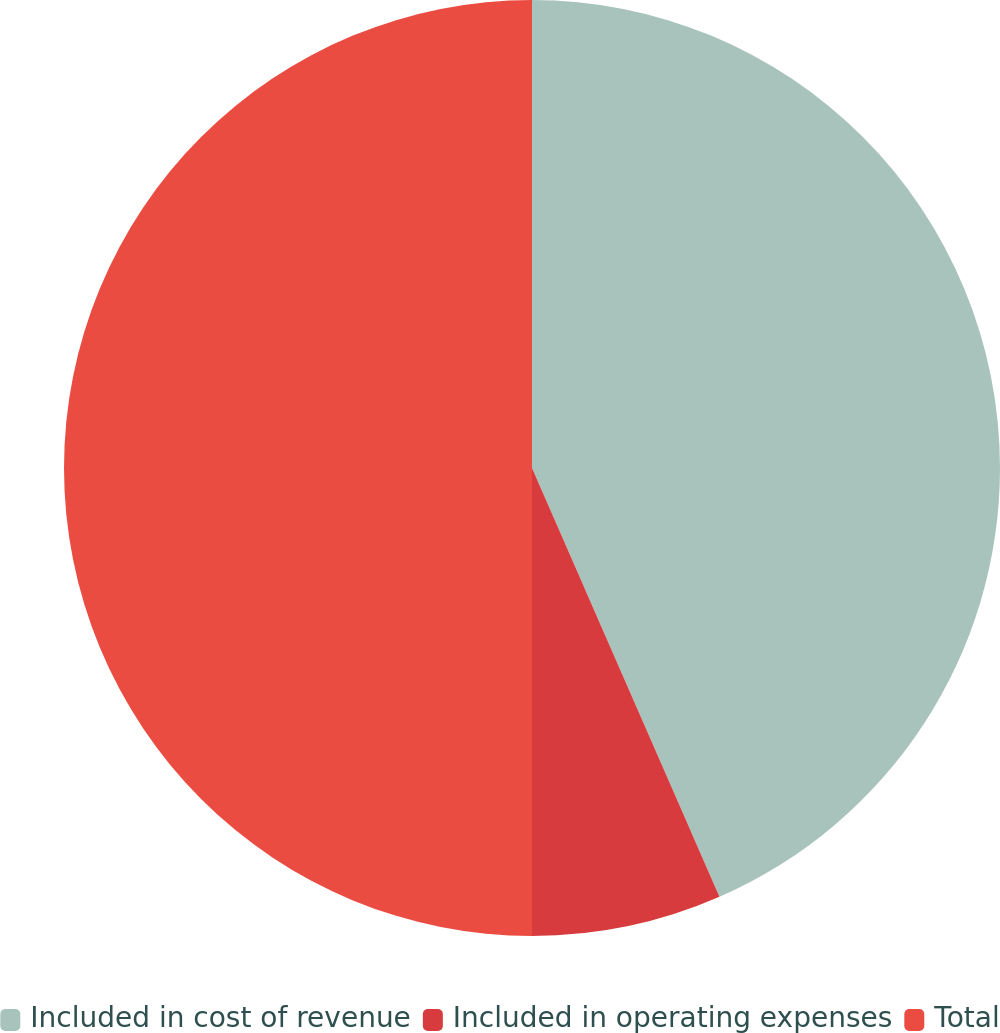Convert chart to OTSL. <chart><loc_0><loc_0><loc_500><loc_500><pie_chart><fcel>Included in cost of revenue<fcel>Included in operating expenses<fcel>Total<nl><fcel>43.44%<fcel>6.56%<fcel>50.0%<nl></chart> 